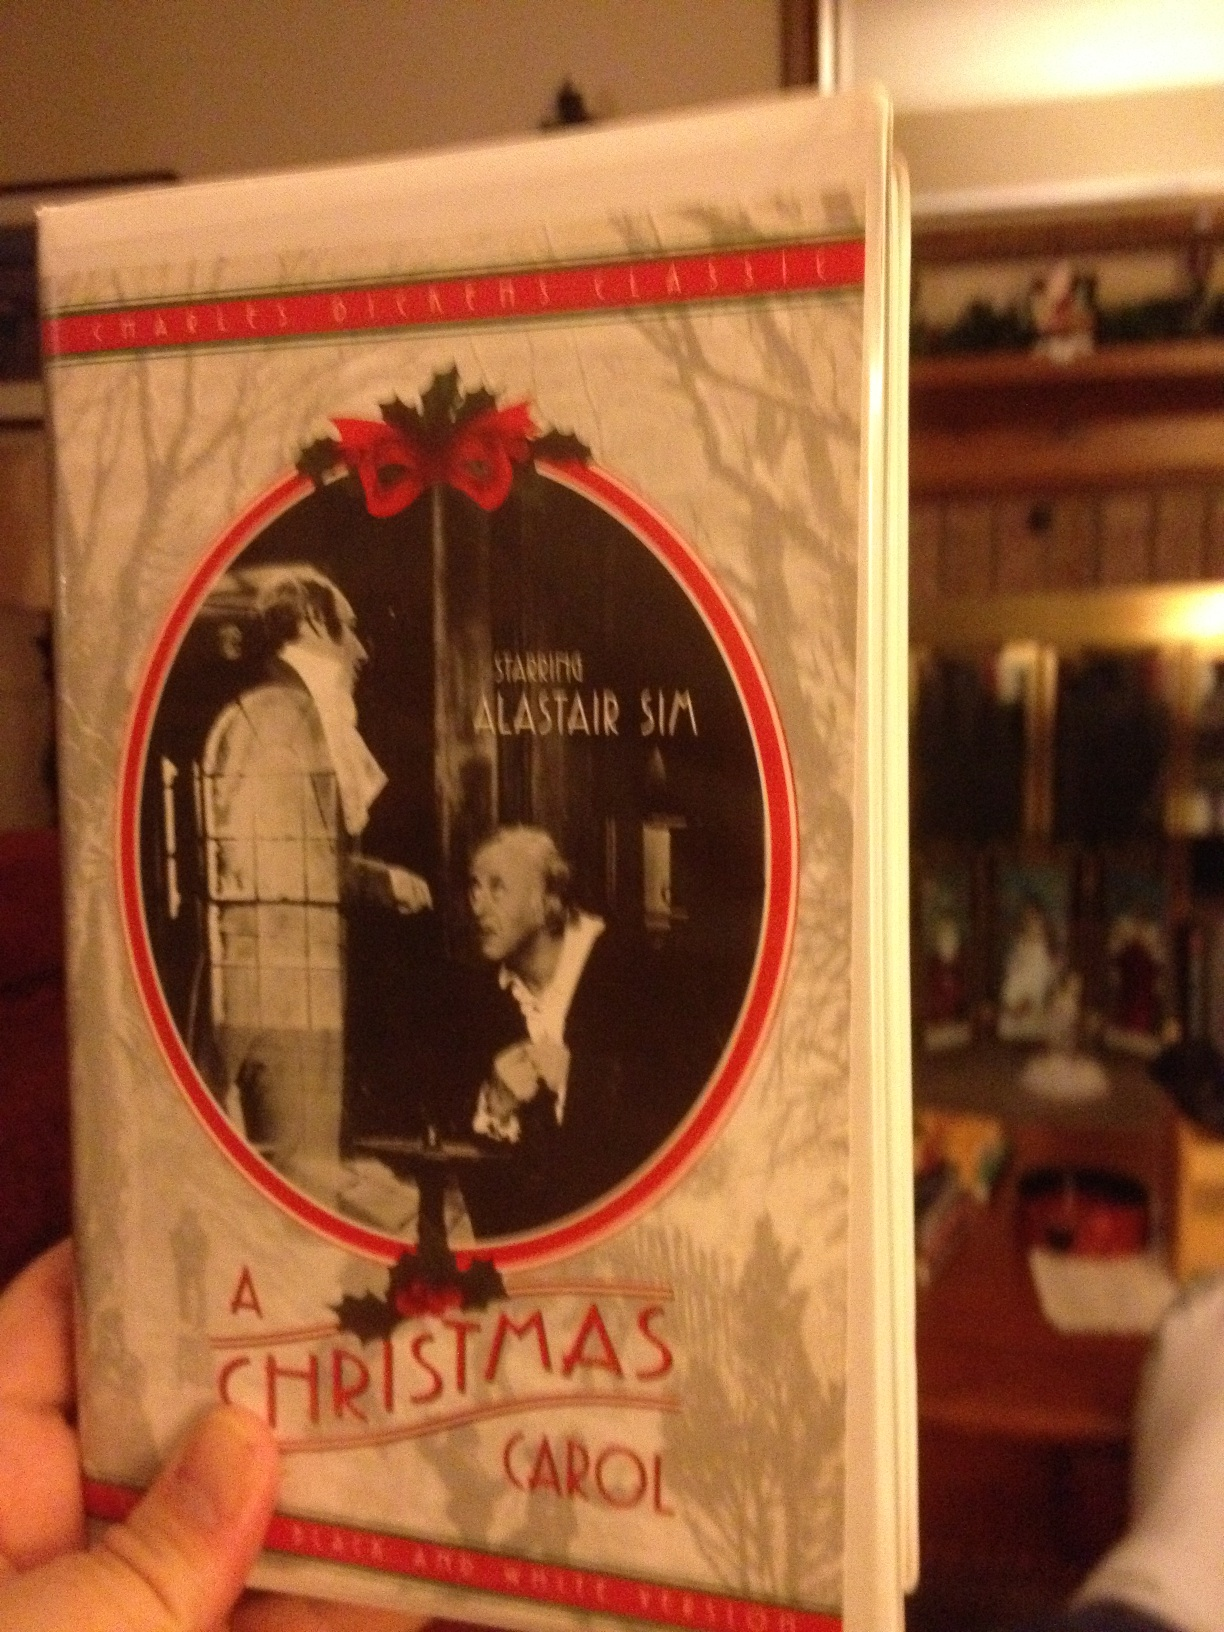What message do you think the author, Charles Dickens, was trying to convey through this story? Charles Dickens penned 'A Christmas Carol' with the intent to critique the social and economic inequalities of his time, while conveying messages of redemption, generosity, and the spirit of Christmas. Through the character of Ebenezer Scrooge, Dickens illustrates the transformative power of self-reflection and kindness. He emphasizes that it is never too late to turn one's life around and make amends for past misdeeds. Additionally, the story underscores the importance of compassion and community, contrasting the warmth and joy of holiday festivities with the coldness of greed and isolation. Dickens intended to inspire readers to embrace the spirit of giving and to recognize the profound impact that caring for one another can have on society as a whole. 